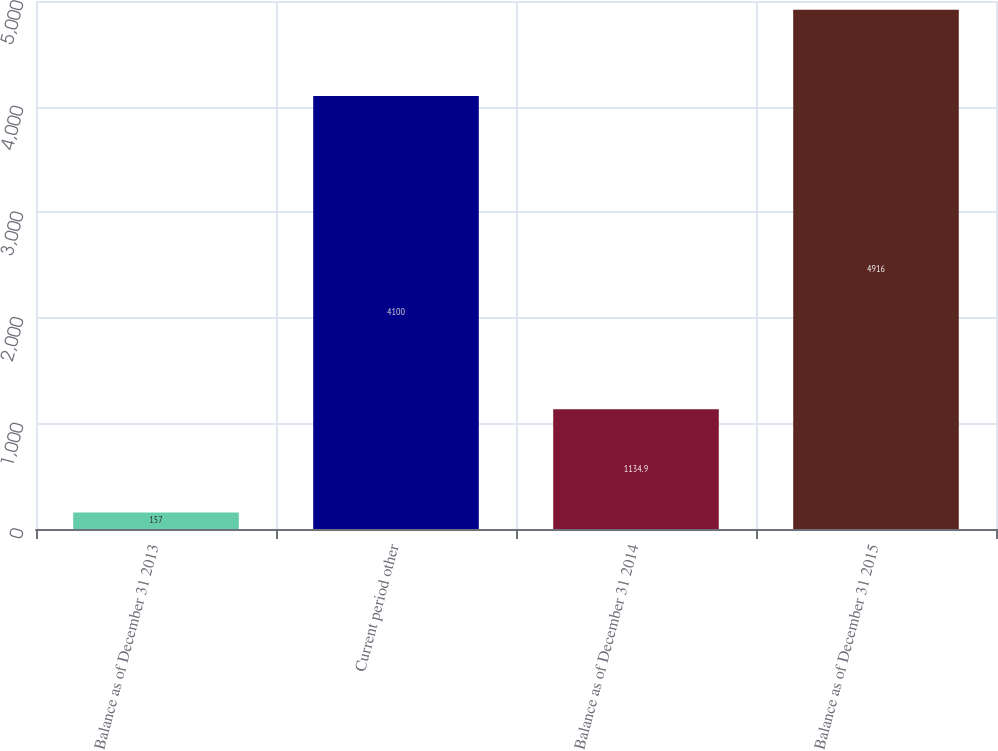Convert chart. <chart><loc_0><loc_0><loc_500><loc_500><bar_chart><fcel>Balance as of December 31 2013<fcel>Current period other<fcel>Balance as of December 31 2014<fcel>Balance as of December 31 2015<nl><fcel>157<fcel>4100<fcel>1134.9<fcel>4916<nl></chart> 